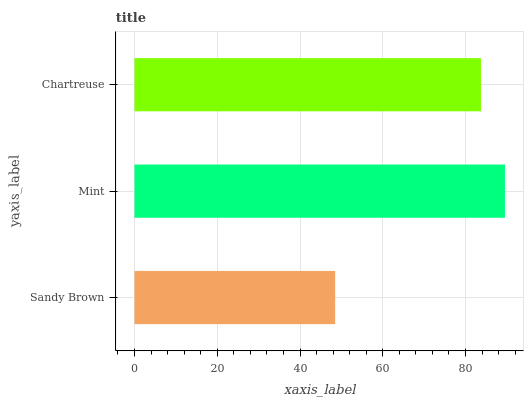Is Sandy Brown the minimum?
Answer yes or no. Yes. Is Mint the maximum?
Answer yes or no. Yes. Is Chartreuse the minimum?
Answer yes or no. No. Is Chartreuse the maximum?
Answer yes or no. No. Is Mint greater than Chartreuse?
Answer yes or no. Yes. Is Chartreuse less than Mint?
Answer yes or no. Yes. Is Chartreuse greater than Mint?
Answer yes or no. No. Is Mint less than Chartreuse?
Answer yes or no. No. Is Chartreuse the high median?
Answer yes or no. Yes. Is Chartreuse the low median?
Answer yes or no. Yes. Is Sandy Brown the high median?
Answer yes or no. No. Is Sandy Brown the low median?
Answer yes or no. No. 